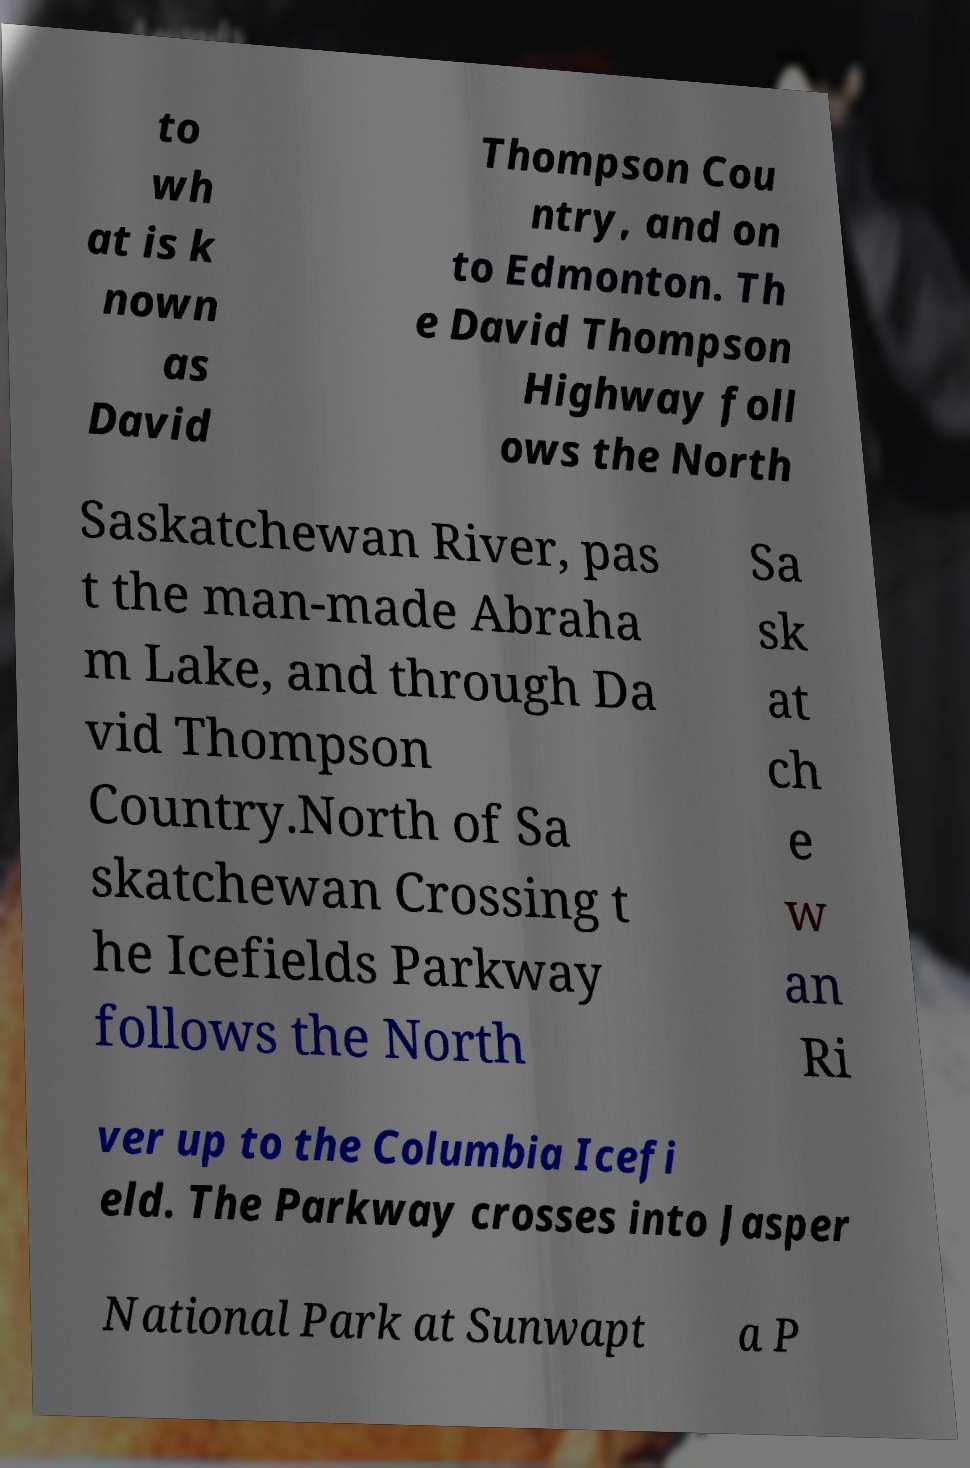Please identify and transcribe the text found in this image. to wh at is k nown as David Thompson Cou ntry, and on to Edmonton. Th e David Thompson Highway foll ows the North Saskatchewan River, pas t the man-made Abraha m Lake, and through Da vid Thompson Country.North of Sa skatchewan Crossing t he Icefields Parkway follows the North Sa sk at ch e w an Ri ver up to the Columbia Icefi eld. The Parkway crosses into Jasper National Park at Sunwapt a P 